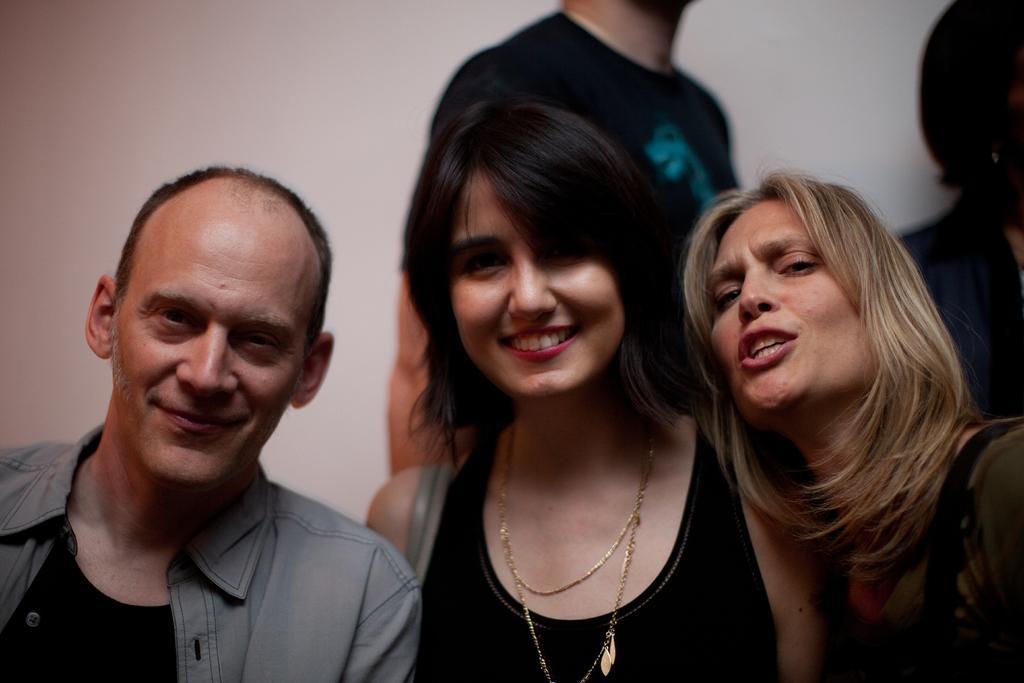Please provide a concise description of this image. In this image I can see two women and a man. I can see two other persons behind them and I can see the white colored background. 